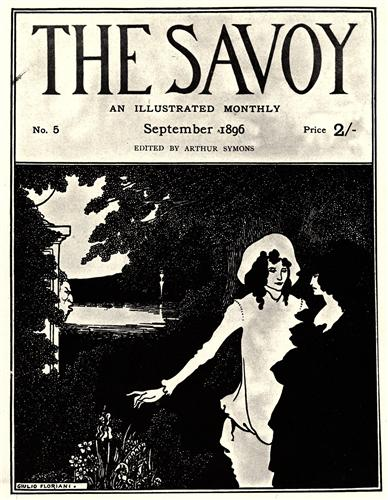Imagine a story behind this image. What might have led the couple to this serene garden setting? It was a late summer afternoon in 1896, and Emily had received a beautifully handwritten letter from her beloved, Henry, asking her to meet him in the garden where they had first declared their love for each other. As Emily walked through the familiar pathways, the memories of their sweet moments together flooded back. She finally reached the spot near the river where Henry was waiting for her, dressed in his best attire. The couple stood close, exchanging words of love and future promises, completely enveloped in the serenity and beauty of the garden. The scene captured in the image is a moment of pure, unspoken affection that would forever remain etched in their hearts.  If this image were to be a part of a larger narrative, what kind of literary elements could be included to enhance the story? To enhance the larger narrative of this image, one could include elements such as a flashback to the couple's first meeting and the blossoming of their romance in different garden settings. Using rich, descriptive language to paint a picture of the changing seasons in the garden would add depth to the narrative. Dialogues that reflect the period's societal norms and challenges the couple faced would create a compelling subplot. Additionally, incorporating letters, diary entries, or even poetry written by the characters could enrich the story, providing deeper insights into their emotions and thoughts. Symbolism could be employed with the garden representing a safe haven amidst the uncertainties of life, thus adding layers of meaning to the narrative. 